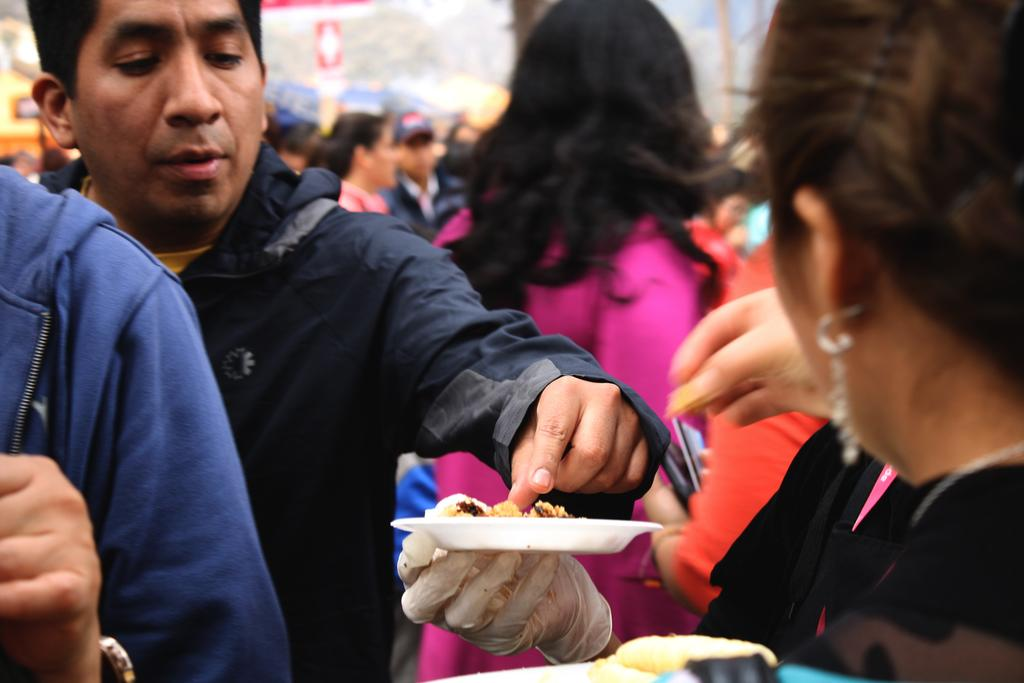Who or what is present in the image? There are people in the image. What else can be seen in the image besides the people? There is a plate with food in the image. How is the plate with food being held? The plate with food is being held by hand. Can you describe the background of the image? The background of the image is blurry. What is the health status of the power range in the image? There is no power range or health status mentioned in the image; it features people and a plate with food. 